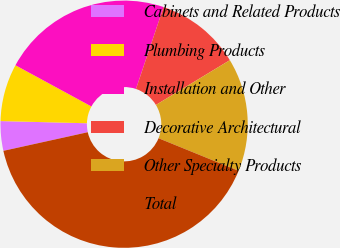Convert chart. <chart><loc_0><loc_0><loc_500><loc_500><pie_chart><fcel>Cabinets and Related Products<fcel>Plumbing Products<fcel>Installation and Other<fcel>Decorative Architectural<fcel>Other Specialty Products<fcel>Total<nl><fcel>3.86%<fcel>7.51%<fcel>22.26%<fcel>11.16%<fcel>14.82%<fcel>40.39%<nl></chart> 